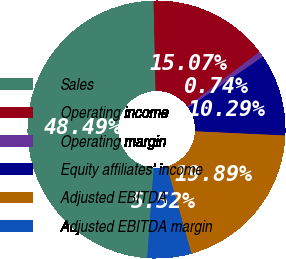<chart> <loc_0><loc_0><loc_500><loc_500><pie_chart><fcel>Sales<fcel>Operating income<fcel>Operating margin<fcel>Equity affiliates' income<fcel>Adjusted EBITDA<fcel>Adjusted EBITDA margin<nl><fcel>48.49%<fcel>15.07%<fcel>0.74%<fcel>10.29%<fcel>19.89%<fcel>5.52%<nl></chart> 